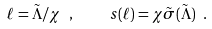<formula> <loc_0><loc_0><loc_500><loc_500>\ell = \tilde { \Lambda } / \chi \ , \quad s ( \ell ) = \chi \tilde { \sigma } ( \tilde { \Lambda } ) \ .</formula> 